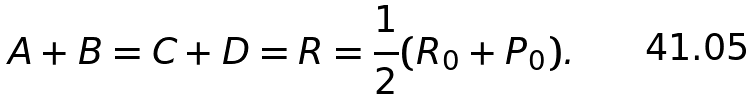<formula> <loc_0><loc_0><loc_500><loc_500>A + B = C + D = R = \frac { 1 } { 2 } ( R _ { 0 } + P _ { 0 } ) .</formula> 